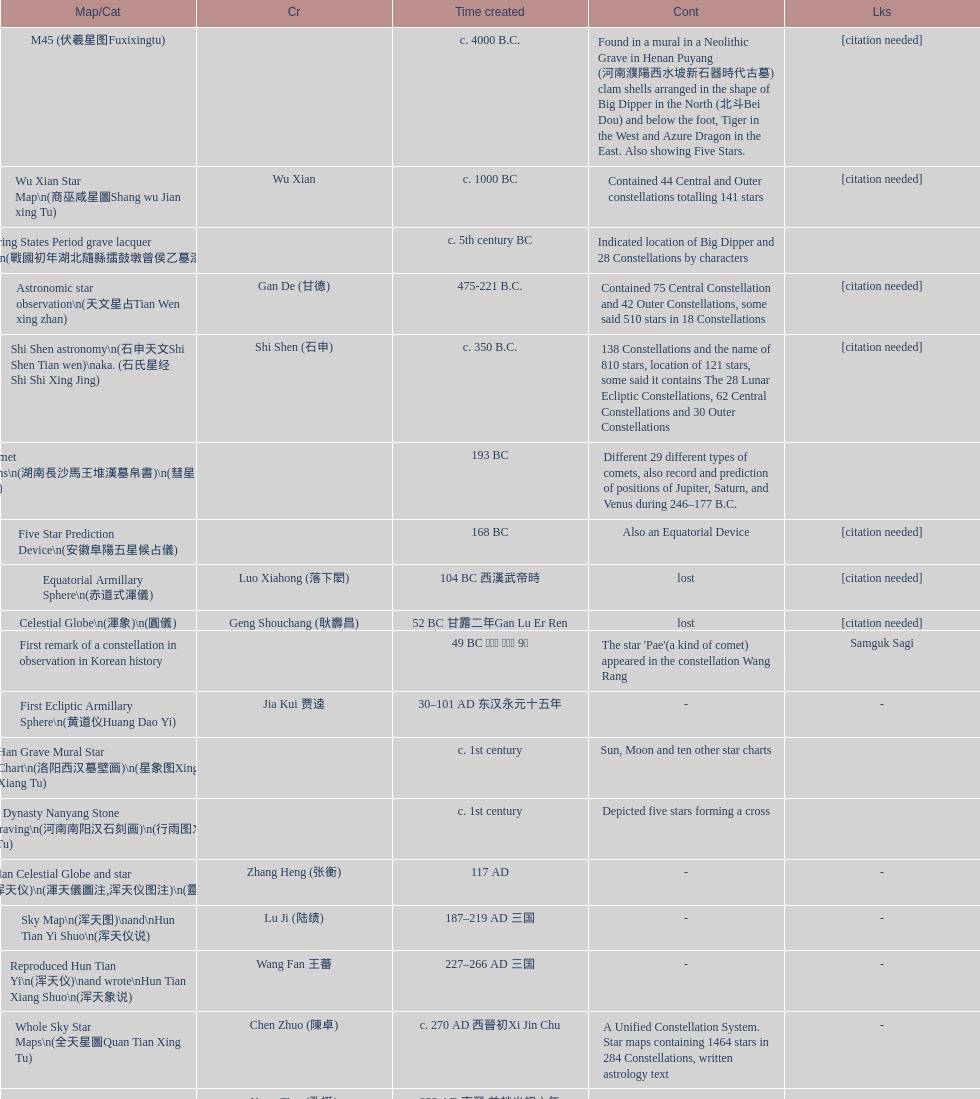Did xu guang ci or su song create the five star charts in 1094 ad? Su Song 蘇頌. 